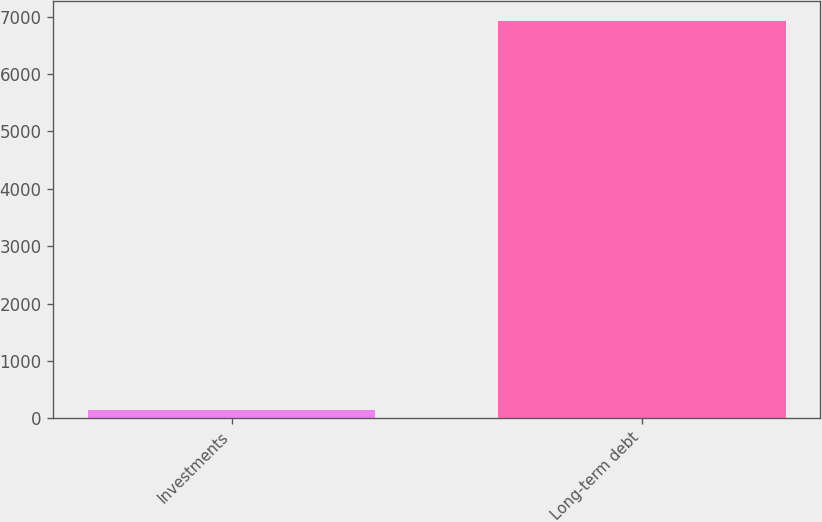Convert chart to OTSL. <chart><loc_0><loc_0><loc_500><loc_500><bar_chart><fcel>Investments<fcel>Long-term debt<nl><fcel>139<fcel>6930<nl></chart> 